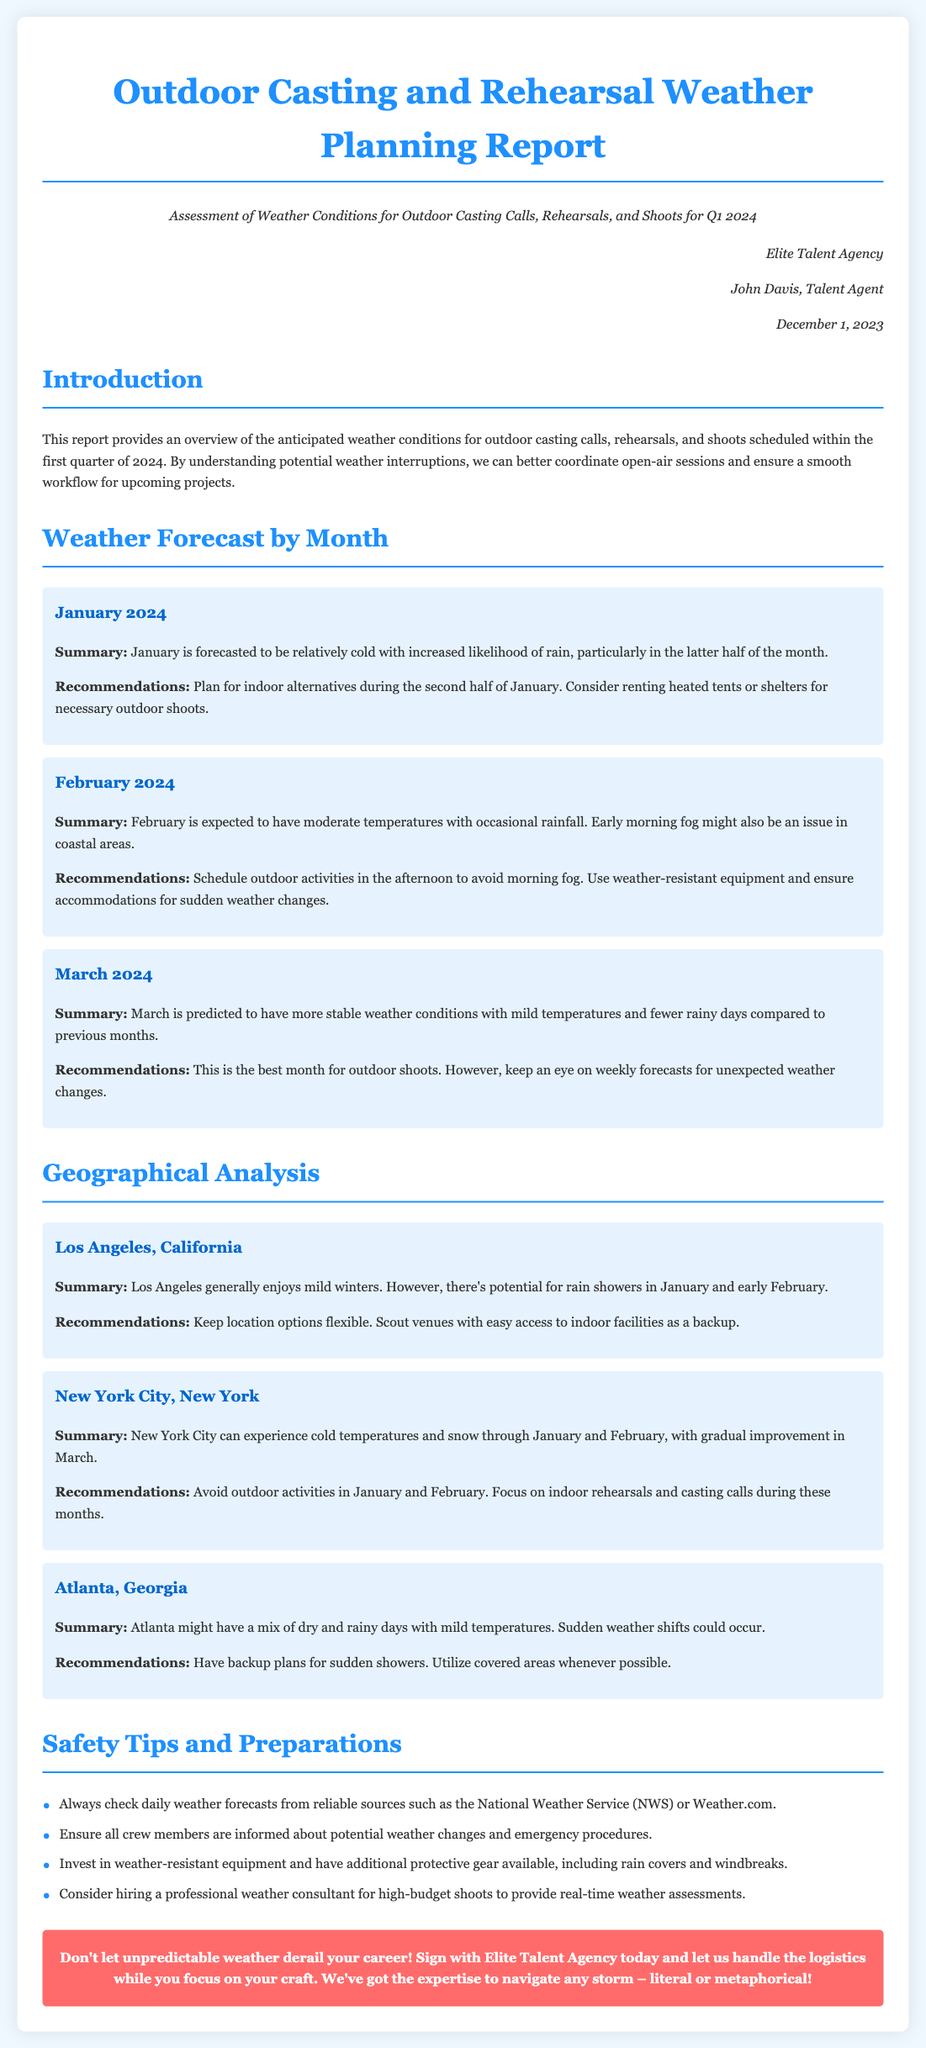what is the title of the report? The title of the report is prominently displayed at the top of the document.
Answer: Outdoor Casting and Rehearsal Weather Planning Report who is the author of the report? The author's name is found in the author info section of the document.
Answer: John Davis what month is forecasted to have moderate temperatures with occasional rainfall? This information is provided in the weather forecast for February.
Answer: February which location is expected to have potential for rain showers in January and early February? The summary for each location highlights specific weather conditions.
Answer: Los Angeles, California what is the recommended backup plan for outdoor activities in Atlanta? Recommendations regarding sudden weather changes are listed under Atlanta's geographical analysis.
Answer: Have backup plans for sudden showers how many months does the report cover? The weather forecast section includes a breakdown by month.
Answer: Three months which month is described as the best for outdoor shoots? The summary for March indicates optimal conditions for outdoor activities.
Answer: March what is one safety tip provided in the report? Safety tips are listed in a bullet format in the safety tips and preparations section.
Answer: Always check daily weather forecasts what is the name of the talent agency? The name of the agency is mentioned in the author info and throughout the document.
Answer: Elite Talent Agency 